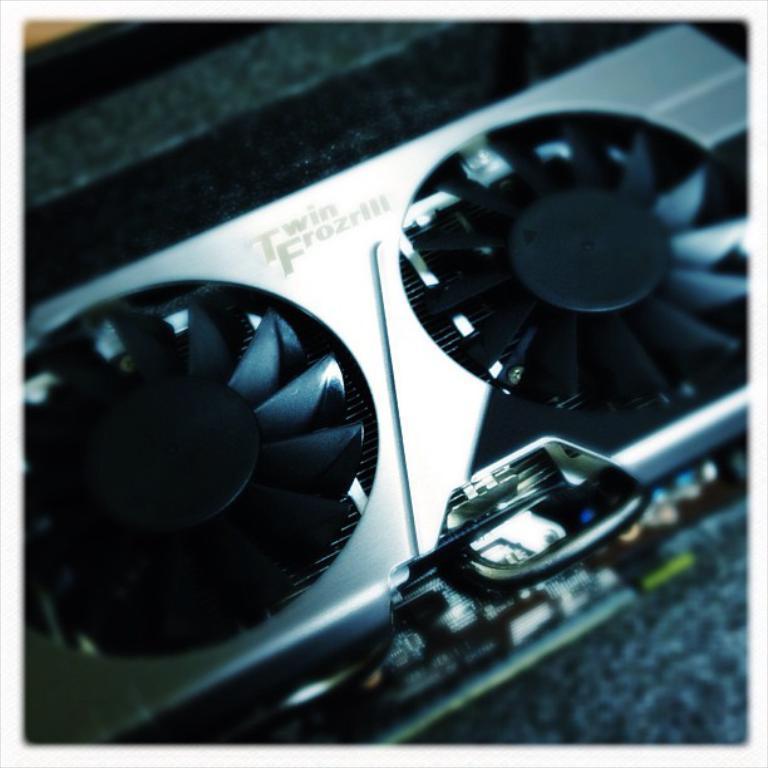How would you summarize this image in a sentence or two? Here in this picture we can see a couple of fans present on an electronic equipment, which is present over there. 